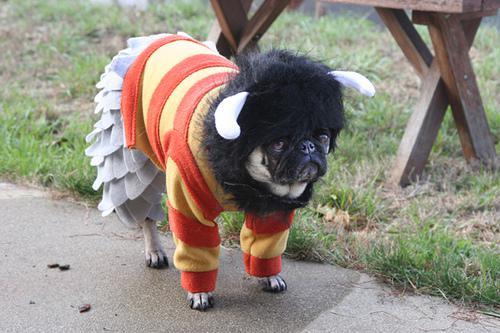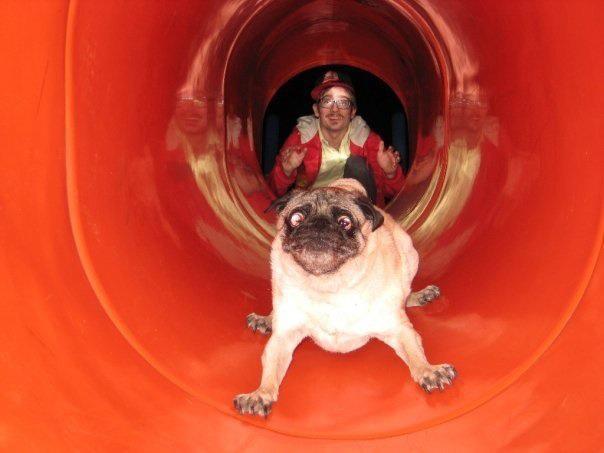The first image is the image on the left, the second image is the image on the right. Evaluate the accuracy of this statement regarding the images: "The left image shows one live pug that is not wearing a costume, and the right image includes a flat-faced dog and a pig snout". Is it true? Answer yes or no. No. The first image is the image on the left, the second image is the image on the right. Evaluate the accuracy of this statement regarding the images: "One of the images features a taxidermy dog.". Is it true? Answer yes or no. No. 